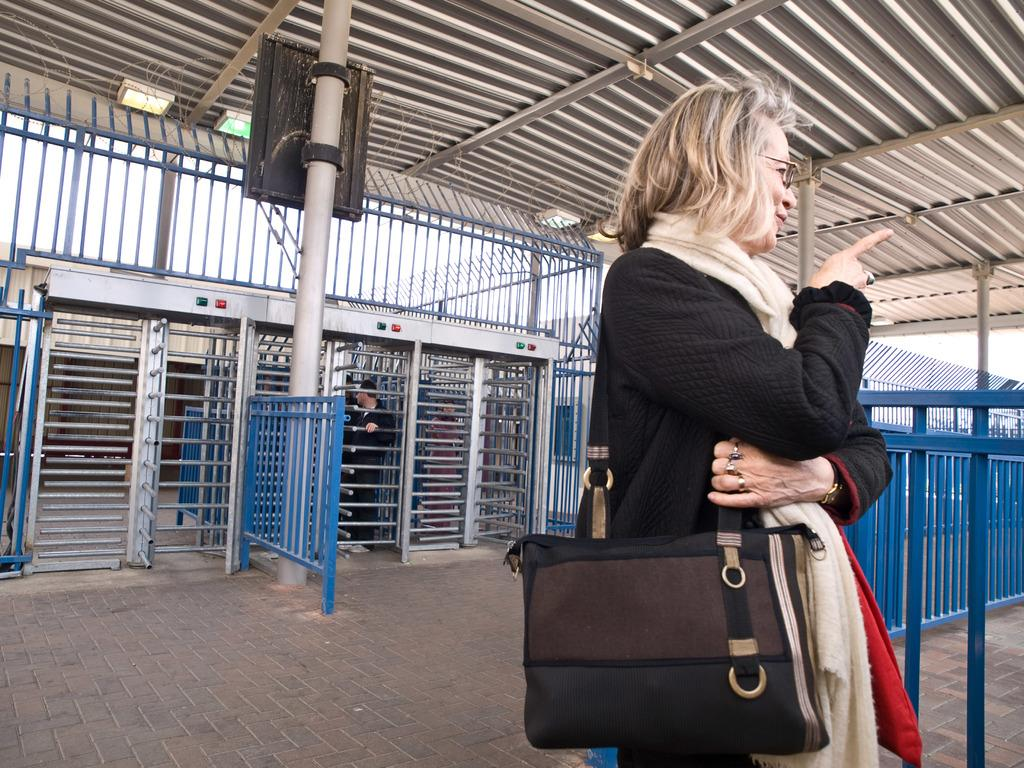What is present in the image? There are women in the image. What are the women wearing? The women are wearing bags. What can be seen in the background of the image? There is an iron gate in the background of the image. Can you tell me how many potatoes are visible in the image? There are no potatoes present in the image. What type of finger can be seen touching the iron gate in the image? There is no finger touching the iron gate in the image; it is not possible to determine if any fingers are present. 